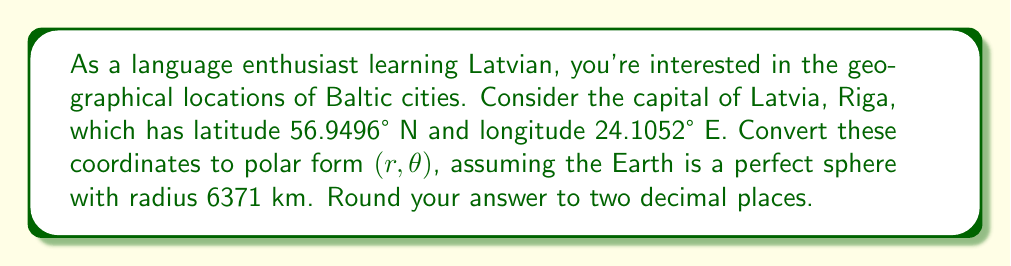Could you help me with this problem? To convert latitude and longitude to polar coordinates, we need to follow these steps:

1) First, convert the latitude and longitude to radians:
   $\text{lat} = 56.9496° \cdot \frac{\pi}{180} = 0.9938 \text{ radians}$
   $\text{lon} = 24.1052° \cdot \frac{\pi}{180} = 0.4207 \text{ radians}$

2) Calculate the radius $r$:
   $r = R \cdot \cos(\text{lat})$
   where $R$ is the Earth's radius (6371 km)
   
   $r = 6371 \cdot \cos(0.9938) = 3510.91 \text{ km}$

3) The angle $\theta$ is simply the longitude in radians:
   $\theta = 0.4207 \text{ radians}$

4) Convert $\theta$ back to degrees:
   $\theta = 0.4207 \cdot \frac{180}{\pi} = 24.11°$

5) Round both values to two decimal places.

Thus, the polar coordinates of Riga are $(3510.91, 24.11°)$.

Note: In this polar coordinate system, the radius represents the distance from the Earth's axis of rotation, and the angle represents the longitude. The North Pole would have $r=0$, and the equator would have $r=R$.
Answer: $(3510.91 \text{ km}, 24.11°)$ 